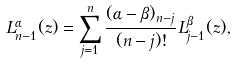Convert formula to latex. <formula><loc_0><loc_0><loc_500><loc_500>L _ { n - 1 } ^ { \alpha } ( z ) = \sum _ { j = 1 } ^ { n } \frac { ( \alpha - \beta ) _ { n - j } } { ( n - j ) ! } L _ { j - 1 } ^ { \beta } ( z ) ,</formula> 